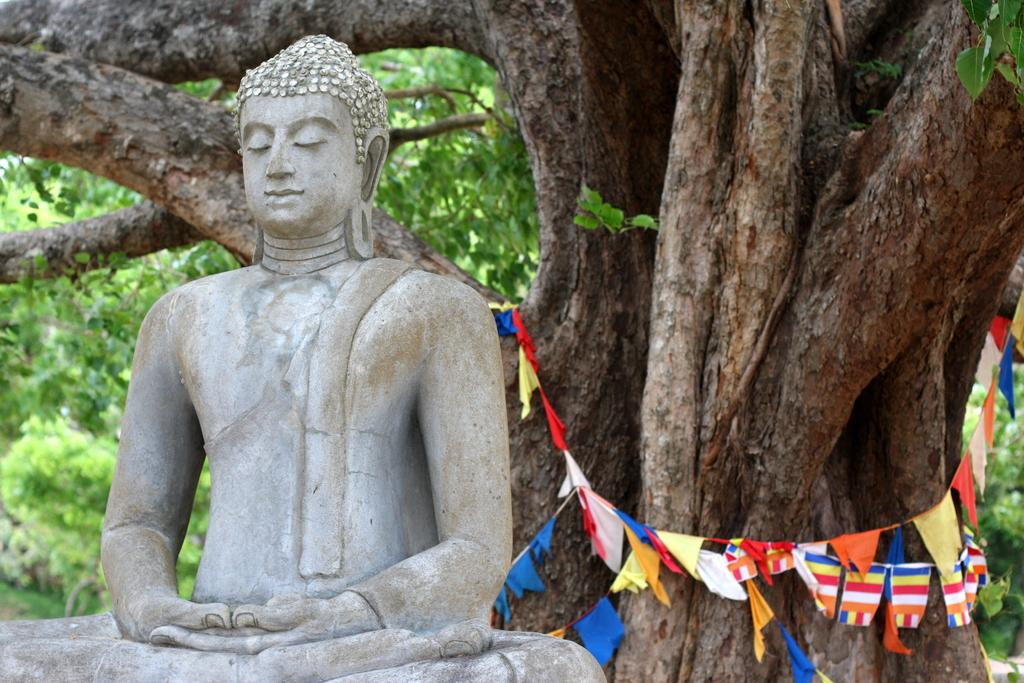What is the main subject of the image? There is a statue of the Buddha in the image. What can be seen in the background of the image? There are flags in multi-color and trees with green color in the background. Where are the beds and drawers located in the image? There are no beds or drawers present in the image. What type of oven can be seen in the image? There is no oven present in the image. 